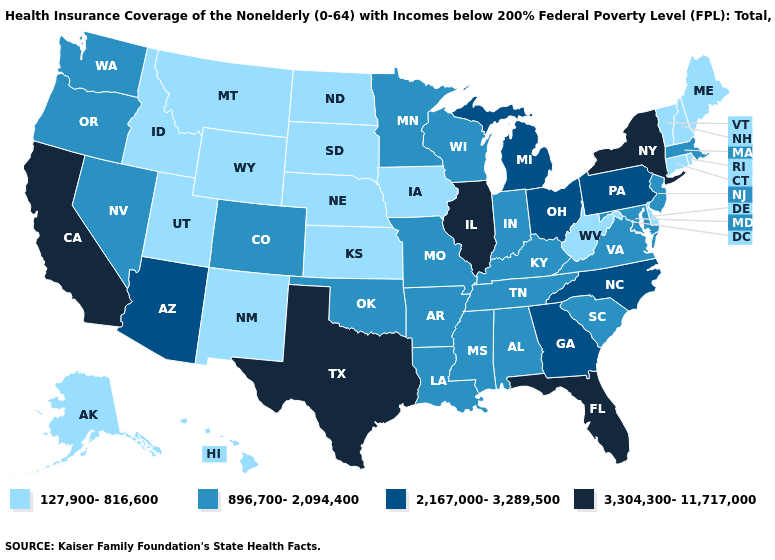Name the states that have a value in the range 127,900-816,600?
Be succinct. Alaska, Connecticut, Delaware, Hawaii, Idaho, Iowa, Kansas, Maine, Montana, Nebraska, New Hampshire, New Mexico, North Dakota, Rhode Island, South Dakota, Utah, Vermont, West Virginia, Wyoming. Does Oregon have the lowest value in the West?
Give a very brief answer. No. What is the lowest value in the USA?
Answer briefly. 127,900-816,600. What is the value of Utah?
Write a very short answer. 127,900-816,600. How many symbols are there in the legend?
Write a very short answer. 4. Among the states that border Missouri , does Illinois have the highest value?
Answer briefly. Yes. What is the highest value in the USA?
Answer briefly. 3,304,300-11,717,000. Does Oregon have the lowest value in the USA?
Answer briefly. No. What is the highest value in states that border Michigan?
Concise answer only. 2,167,000-3,289,500. What is the highest value in the West ?
Short answer required. 3,304,300-11,717,000. Does the first symbol in the legend represent the smallest category?
Quick response, please. Yes. What is the value of Florida?
Be succinct. 3,304,300-11,717,000. Name the states that have a value in the range 3,304,300-11,717,000?
Give a very brief answer. California, Florida, Illinois, New York, Texas. What is the value of Illinois?
Give a very brief answer. 3,304,300-11,717,000. How many symbols are there in the legend?
Keep it brief. 4. 